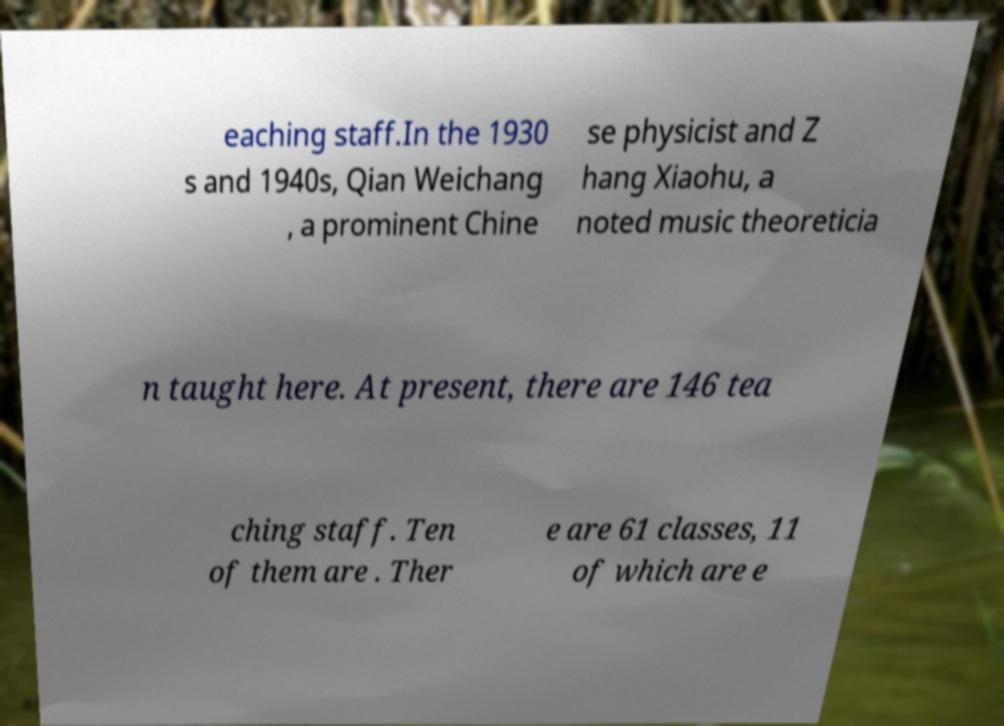Could you extract and type out the text from this image? eaching staff.In the 1930 s and 1940s, Qian Weichang , a prominent Chine se physicist and Z hang Xiaohu, a noted music theoreticia n taught here. At present, there are 146 tea ching staff. Ten of them are . Ther e are 61 classes, 11 of which are e 